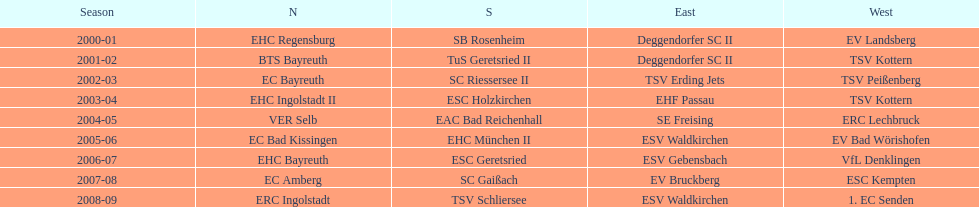How many champions are listend in the north? 9. 